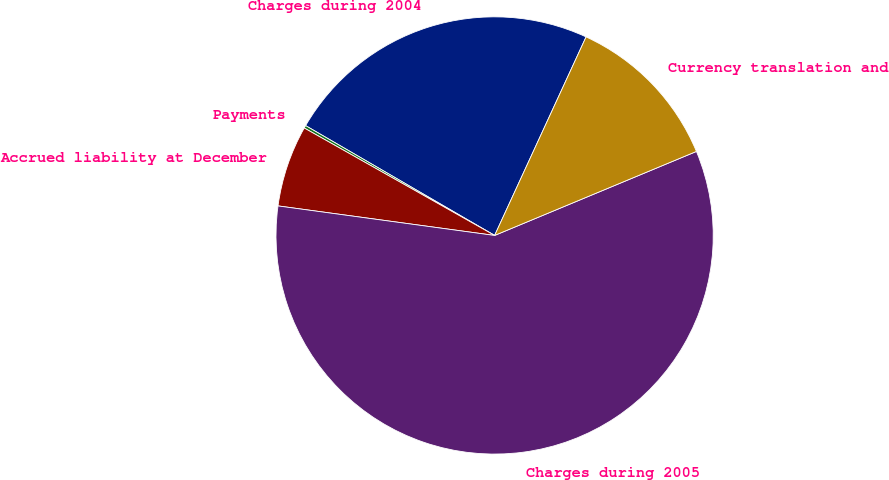<chart> <loc_0><loc_0><loc_500><loc_500><pie_chart><fcel>Charges during 2004<fcel>Payments<fcel>Accrued liability at December<fcel>Charges during 2005<fcel>Currency translation and<nl><fcel>23.49%<fcel>0.2%<fcel>6.02%<fcel>58.43%<fcel>11.85%<nl></chart> 